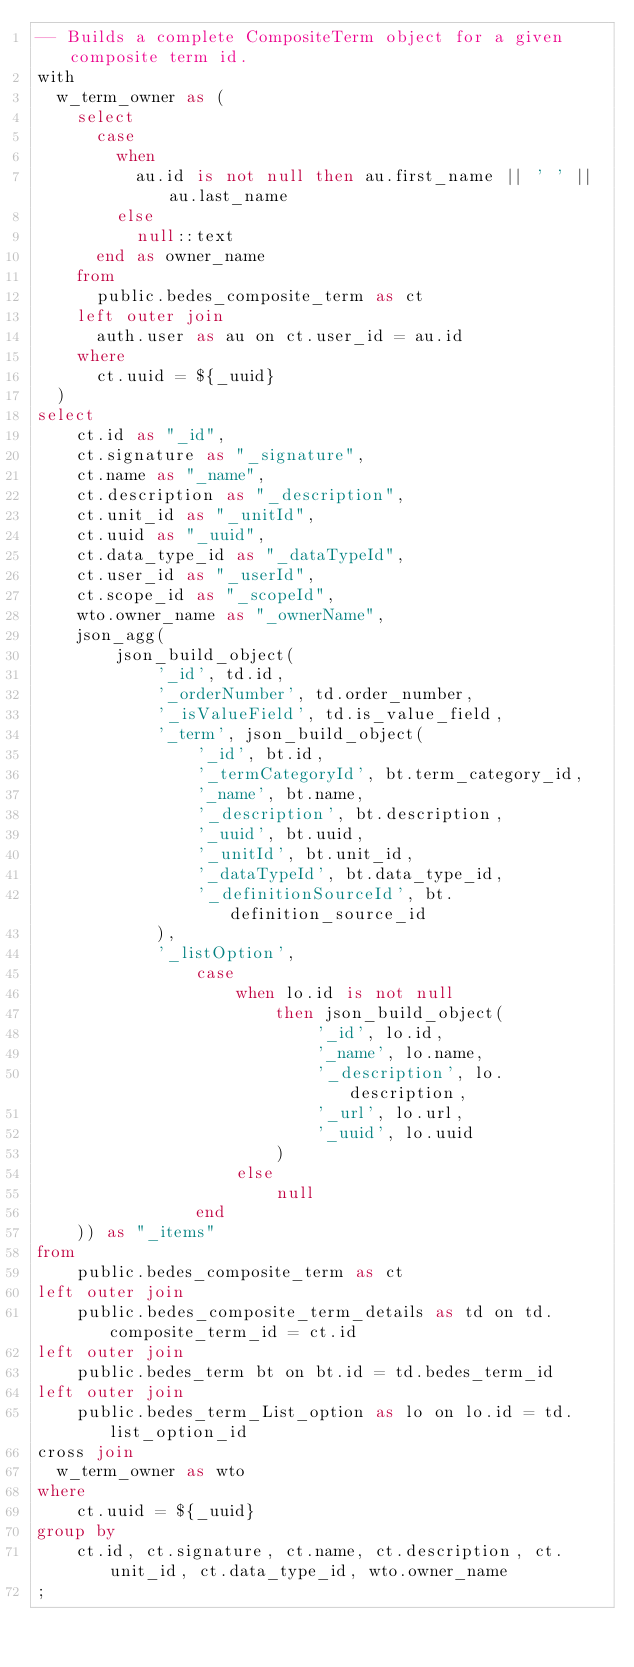<code> <loc_0><loc_0><loc_500><loc_500><_SQL_>-- Builds a complete CompositeTerm object for a given composite term id.
with
	w_term_owner as (
		select
			case
				when
					au.id is not null then au.first_name || ' ' || au.last_name
				else
					null::text
			end as owner_name
		from
			public.bedes_composite_term as ct
		left outer join
			auth.user as au on ct.user_id = au.id
		where
			ct.uuid = ${_uuid}
	)
select
    ct.id as "_id",
    ct.signature as "_signature",
    ct.name as "_name",
    ct.description as "_description",
    ct.unit_id as "_unitId",
    ct.uuid as "_uuid",
    ct.data_type_id as "_dataTypeId",
    ct.user_id as "_userId",
    ct.scope_id as "_scopeId",
    wto.owner_name as "_ownerName",
    json_agg(
        json_build_object(
            '_id', td.id,
            '_orderNumber', td.order_number,
            '_isValueField', td.is_value_field,
            '_term', json_build_object(
                '_id', bt.id,
                '_termCategoryId', bt.term_category_id,
                '_name', bt.name,
                '_description', bt.description,
                '_uuid', bt.uuid,
                '_unitId', bt.unit_id,
                '_dataTypeId', bt.data_type_id,
                '_definitionSourceId', bt.definition_source_id
            ),
            '_listOption', 
                case
                    when lo.id is not null
                        then json_build_object(
                            '_id', lo.id,
                            '_name', lo.name,
                            '_description', lo.description,
                            '_url', lo.url,
                            '_uuid', lo.uuid
                        )
                    else
                        null
                end    
    )) as "_items"
from
    public.bedes_composite_term as ct
left outer join
    public.bedes_composite_term_details as td on td.composite_term_id = ct.id
left outer join
    public.bedes_term bt on bt.id = td.bedes_term_id
left outer join
    public.bedes_term_List_option as lo on lo.id = td.list_option_id
cross join
	w_term_owner as wto
where
    ct.uuid = ${_uuid}
group by
    ct.id, ct.signature, ct.name, ct.description, ct.unit_id, ct.data_type_id, wto.owner_name
;</code> 